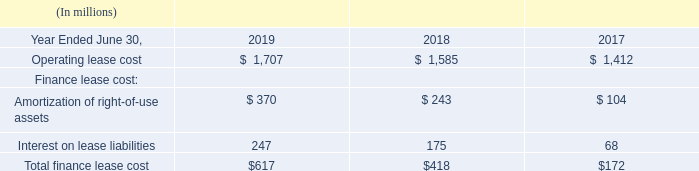NOTE 15 — LEASES
We have operating and finance leases for datacenters, corporate offices, research and development facilities, retail stores, and certain equipment. Our leases have remaining lease terms of 1 year to 20 years, some of which include options to extend the leases for up to 5 years, and some of which include options to terminate the leases within 1 year.
The components of lease expense were as follows:
Which places does the company have operating and finance leases? We have operating and finance leases for datacenters, corporate offices, research and development facilities, retail stores, and certain equipment. What is note 15 about? Leases. How long are the remaining lease terms for? Our leases have remaining lease terms of 1 year to 20 years,. How many finance lease cost items are there? Amortization of right-of-use assets## Interest on lease liabilities
Answer: 2. How much will the operating lease cost be for 2020 if $507 million of leases could be terminated in 1 year?
Answer scale should be: million. 1,707-507
Answer: 1200. What are the years sorted by total finance lease cost, in ascending order? 617##418##172
Answer: 2019, 2018, 2017. 